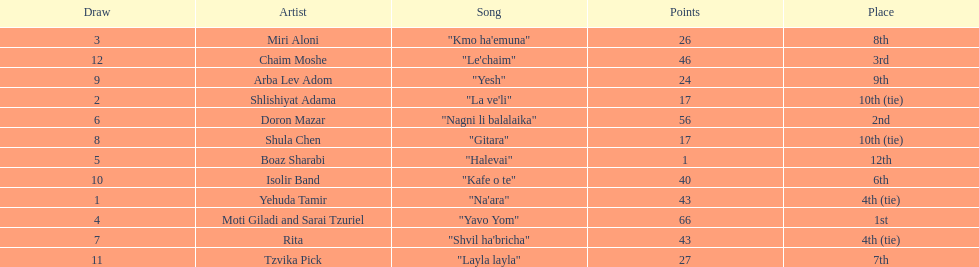What are the number of times an artist earned first place? 1. 